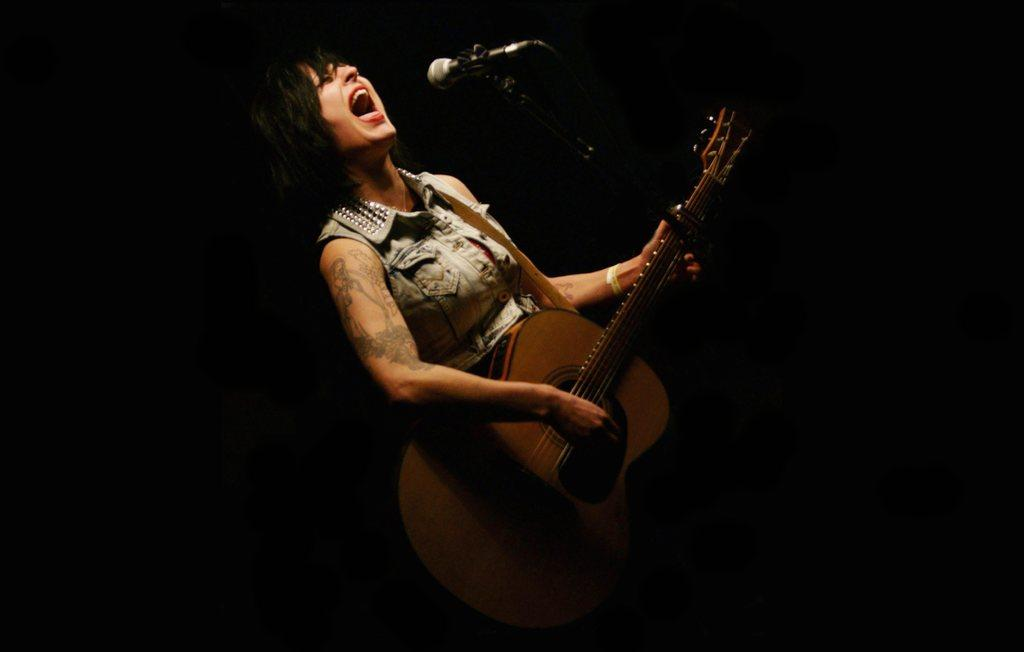Who is the main subject in the image? There is a woman in the image. What is the woman doing in the image? The woman is in front of a microphone and holding a guitar. What can be seen in the background of the image? The background of the image is dark. What type of bike is parked in the room behind the woman? There is no bike present in the image. What company does the woman represent in the image? The image does not provide any information about the company the woman might represent. 